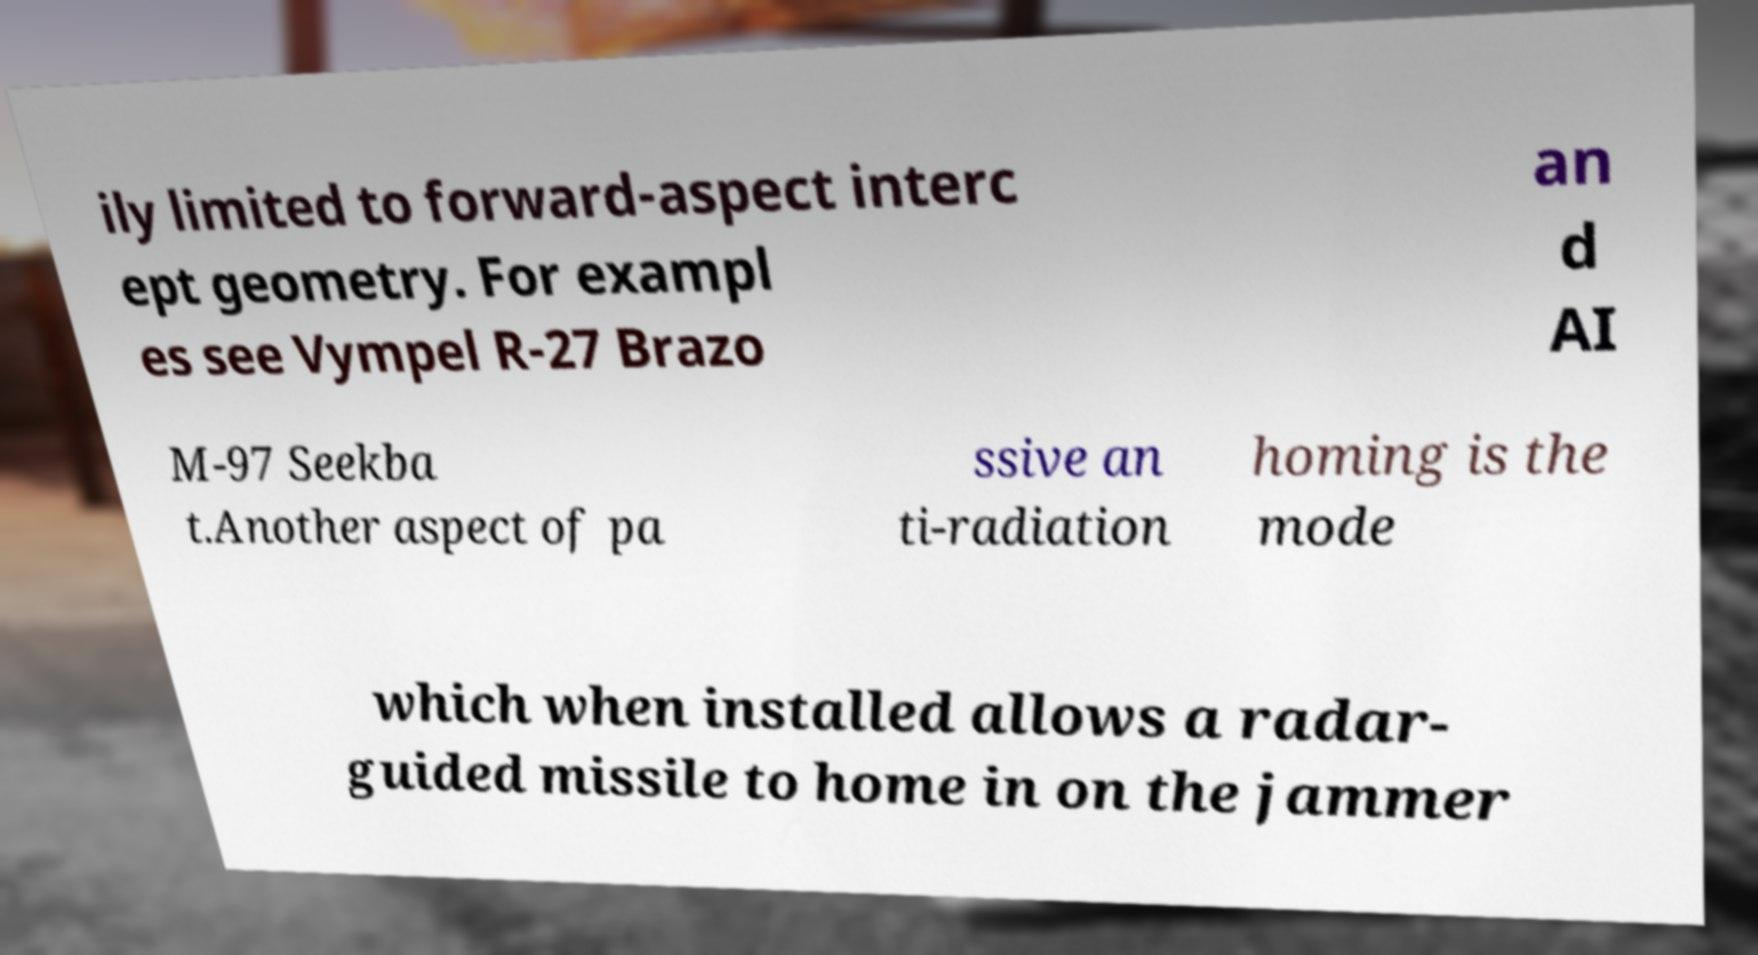Could you extract and type out the text from this image? ily limited to forward-aspect interc ept geometry. For exampl es see Vympel R-27 Brazo an d AI M-97 Seekba t.Another aspect of pa ssive an ti-radiation homing is the mode which when installed allows a radar- guided missile to home in on the jammer 